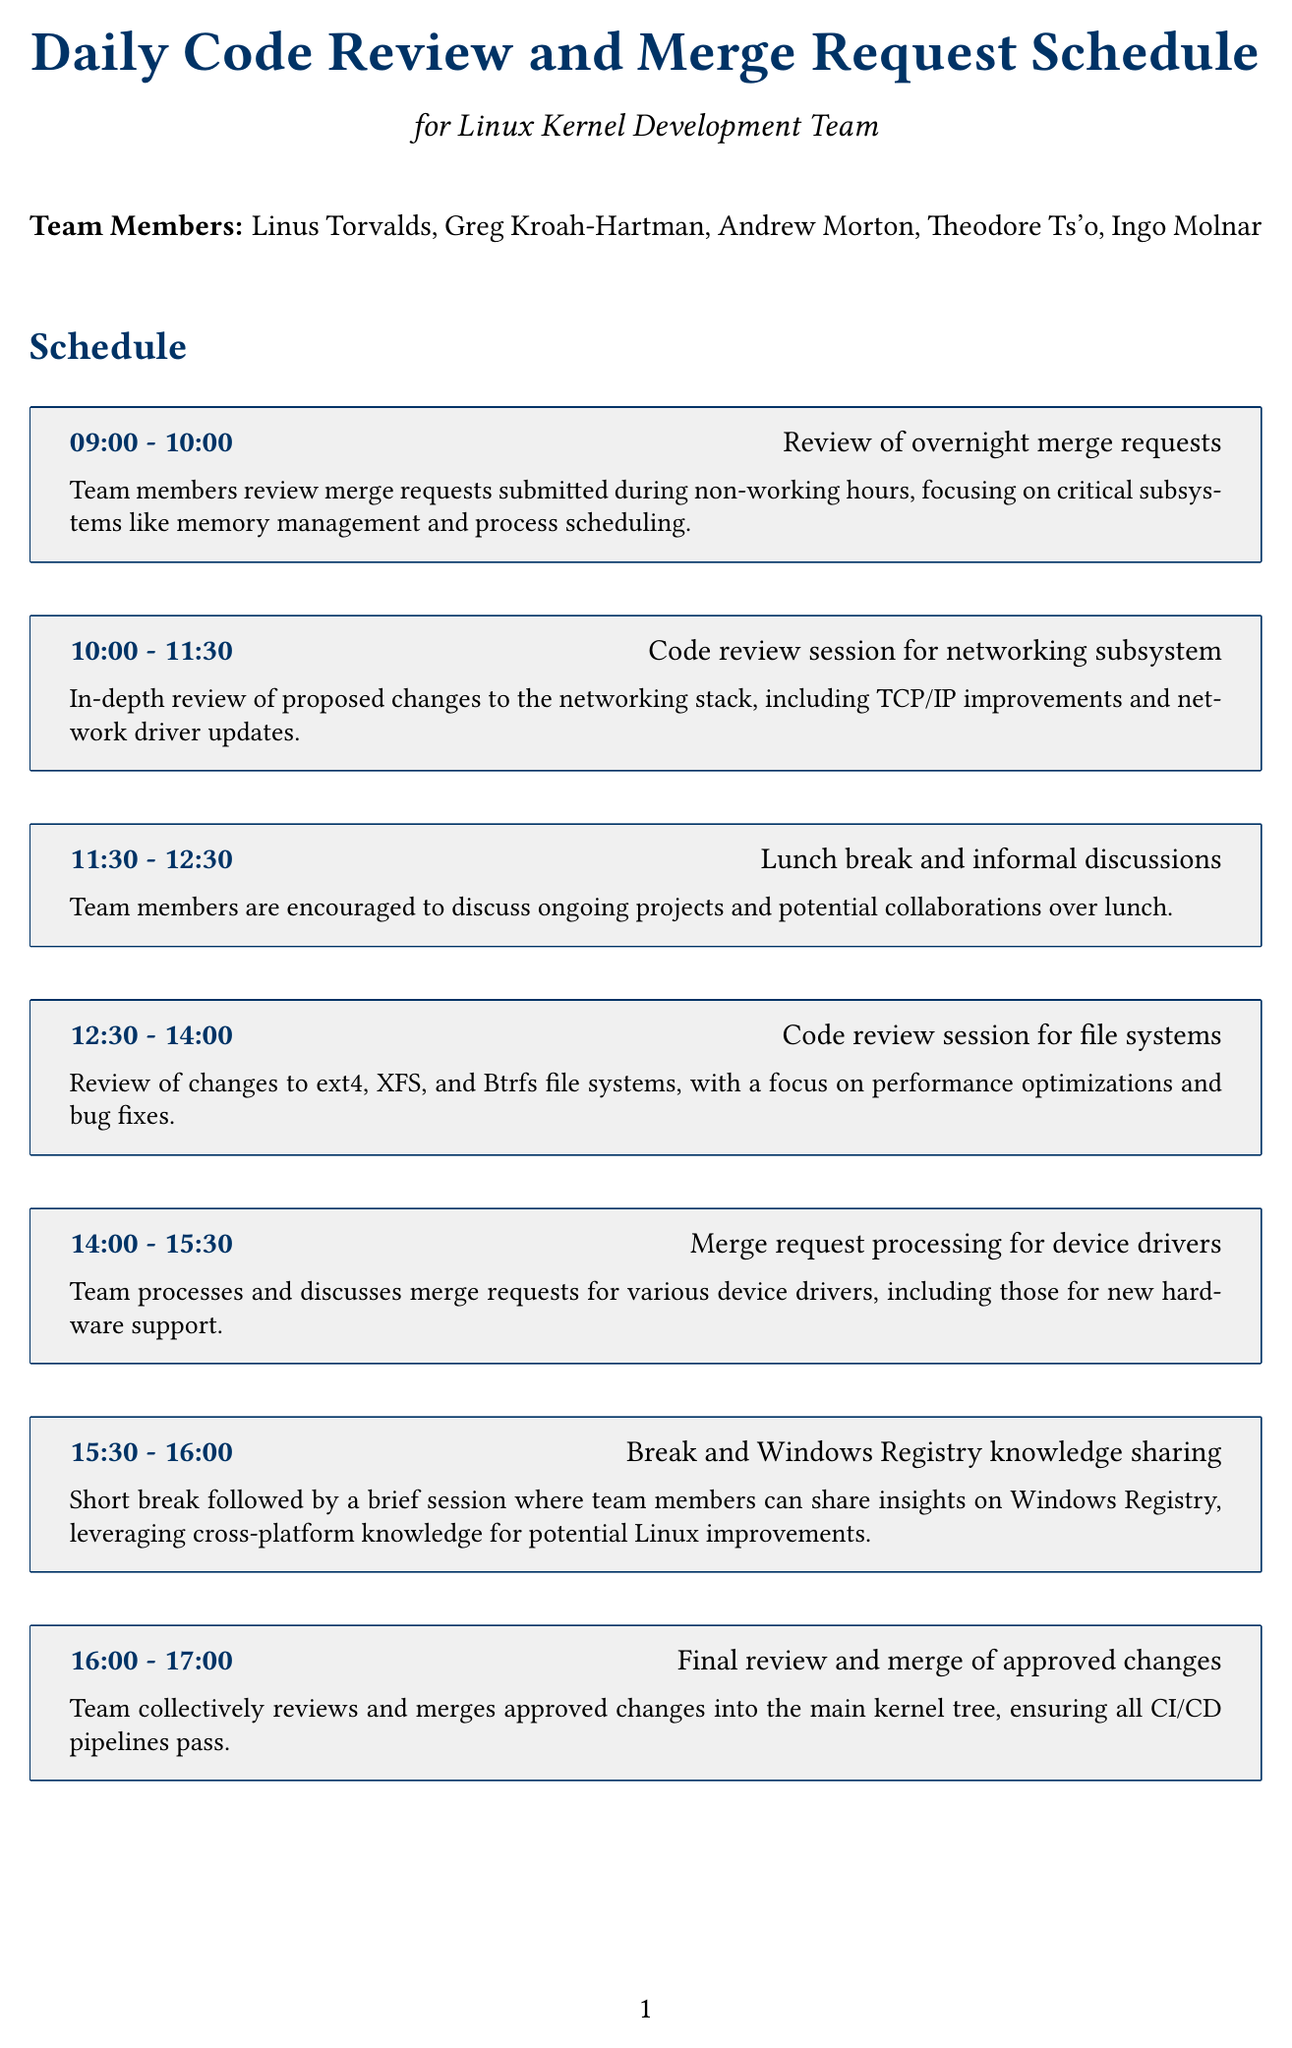what is the schedule title? The schedule title is specified at the beginning of the document, setting the theme for the daily activities.
Answer: Daily Code Review and Merge Request Schedule for Linux Kernel Development Team who are the team members? The document lists the names of all team members involved in the review and merge process.
Answer: Linus Torvalds, Greg Kroah-Hartman, Andrew Morton, Theodore Ts'o, Ingo Molnar what time is the lunch break? The timing for the lunch break is highlighted in the schedule section which helps in planning the day's activities.
Answer: 11:30 - 12:30 how long is the code review session for networking subsystem? The duration of the networking subsystem code review session is specified in the schedule.
Answer: 1 hour 30 minutes what activity takes place at 15:30? The activity listed at this time is related to knowledge sharing, which is an important part of team discussions.
Answer: Break and Windows Registry knowledge sharing what focus area is related to security? The key focus areas include various aspects that the team aims to improve, one of which is specifically emphasized.
Answer: Security enhancements how many tools and resources are listed? The number of tools and resources indicates the variety of support available for the development processes.
Answer: 5 what is the final activity of the day? The last activity mentioned in the schedule is meant to review the day's work and plan for the following day.
Answer: Daily wrap-up and planning for tomorrow what is the purpose of Git? The purpose of each tool and resource is outlined to understand their roles in the development process.
Answer: Version control system for managing kernel source code 